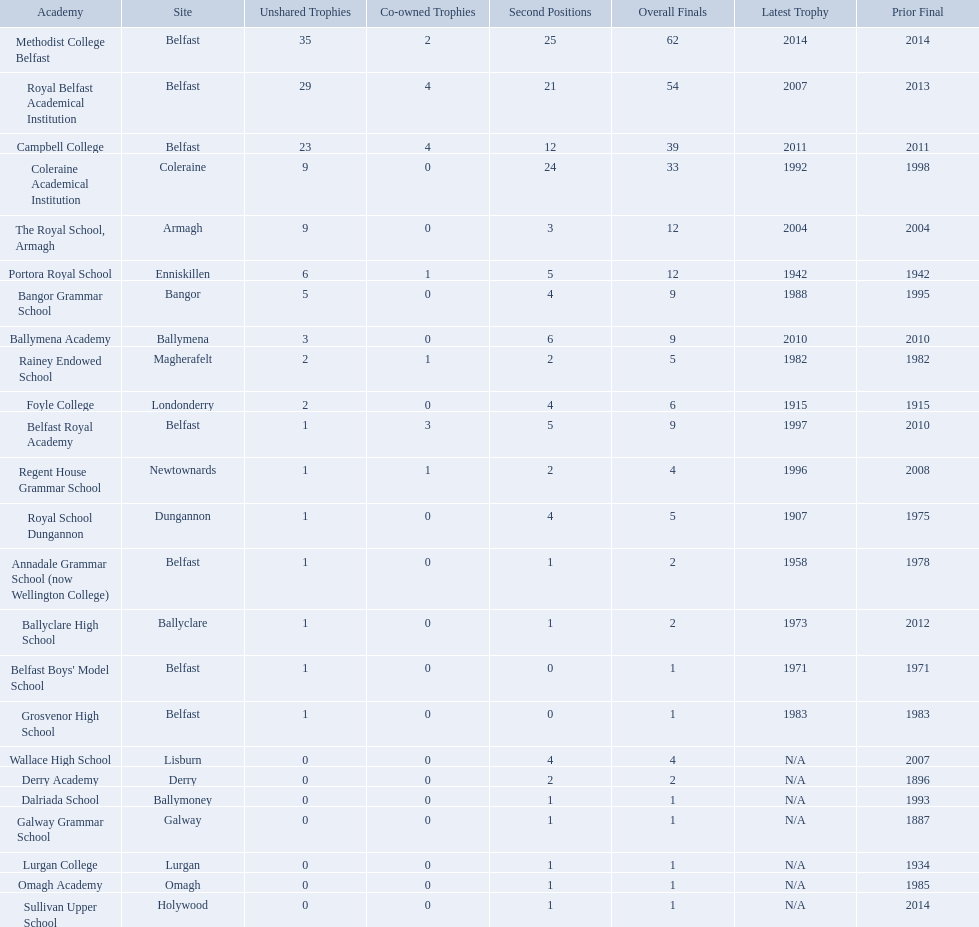What were all of the school names? Methodist College Belfast, Royal Belfast Academical Institution, Campbell College, Coleraine Academical Institution, The Royal School, Armagh, Portora Royal School, Bangor Grammar School, Ballymena Academy, Rainey Endowed School, Foyle College, Belfast Royal Academy, Regent House Grammar School, Royal School Dungannon, Annadale Grammar School (now Wellington College), Ballyclare High School, Belfast Boys' Model School, Grosvenor High School, Wallace High School, Derry Academy, Dalriada School, Galway Grammar School, Lurgan College, Omagh Academy, Sullivan Upper School. How many outright titles did they achieve? 35, 29, 23, 9, 9, 6, 5, 3, 2, 2, 1, 1, 1, 1, 1, 1, 1, 0, 0, 0, 0, 0, 0, 0. And how many did coleraine academical institution receive? 9. Which other school had the same number of outright titles? The Royal School, Armagh. 